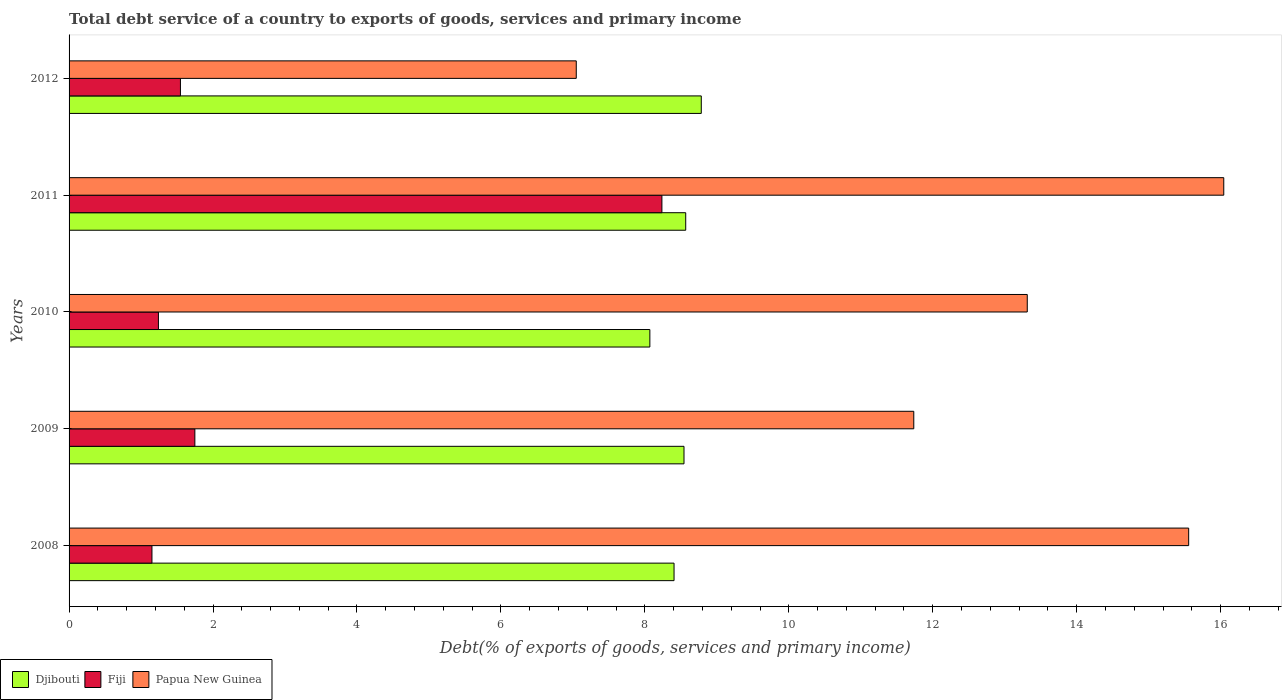How many different coloured bars are there?
Ensure brevity in your answer.  3. How many groups of bars are there?
Provide a short and direct response. 5. Are the number of bars per tick equal to the number of legend labels?
Offer a very short reply. Yes. What is the label of the 3rd group of bars from the top?
Ensure brevity in your answer.  2010. What is the total debt service in Papua New Guinea in 2010?
Your answer should be compact. 13.31. Across all years, what is the maximum total debt service in Papua New Guinea?
Keep it short and to the point. 16.04. Across all years, what is the minimum total debt service in Papua New Guinea?
Your answer should be very brief. 7.05. In which year was the total debt service in Fiji minimum?
Ensure brevity in your answer.  2008. What is the total total debt service in Fiji in the graph?
Provide a short and direct response. 13.93. What is the difference between the total debt service in Fiji in 2008 and that in 2011?
Your answer should be very brief. -7.09. What is the difference between the total debt service in Djibouti in 2009 and the total debt service in Fiji in 2008?
Your response must be concise. 7.39. What is the average total debt service in Djibouti per year?
Your answer should be compact. 8.47. In the year 2009, what is the difference between the total debt service in Fiji and total debt service in Papua New Guinea?
Offer a very short reply. -9.99. What is the ratio of the total debt service in Djibouti in 2010 to that in 2012?
Your response must be concise. 0.92. What is the difference between the highest and the second highest total debt service in Fiji?
Provide a succinct answer. 6.49. What is the difference between the highest and the lowest total debt service in Fiji?
Keep it short and to the point. 7.09. What does the 2nd bar from the top in 2010 represents?
Your response must be concise. Fiji. What does the 3rd bar from the bottom in 2012 represents?
Make the answer very short. Papua New Guinea. Is it the case that in every year, the sum of the total debt service in Papua New Guinea and total debt service in Fiji is greater than the total debt service in Djibouti?
Keep it short and to the point. No. Does the graph contain any zero values?
Ensure brevity in your answer.  No. Does the graph contain grids?
Offer a very short reply. No. Where does the legend appear in the graph?
Provide a short and direct response. Bottom left. How many legend labels are there?
Offer a terse response. 3. What is the title of the graph?
Offer a terse response. Total debt service of a country to exports of goods, services and primary income. What is the label or title of the X-axis?
Your answer should be compact. Debt(% of exports of goods, services and primary income). What is the label or title of the Y-axis?
Your answer should be compact. Years. What is the Debt(% of exports of goods, services and primary income) of Djibouti in 2008?
Provide a succinct answer. 8.41. What is the Debt(% of exports of goods, services and primary income) in Fiji in 2008?
Your answer should be very brief. 1.15. What is the Debt(% of exports of goods, services and primary income) of Papua New Guinea in 2008?
Offer a very short reply. 15.56. What is the Debt(% of exports of goods, services and primary income) of Djibouti in 2009?
Your answer should be compact. 8.54. What is the Debt(% of exports of goods, services and primary income) of Fiji in 2009?
Offer a terse response. 1.75. What is the Debt(% of exports of goods, services and primary income) of Papua New Guinea in 2009?
Your response must be concise. 11.74. What is the Debt(% of exports of goods, services and primary income) of Djibouti in 2010?
Make the answer very short. 8.07. What is the Debt(% of exports of goods, services and primary income) in Fiji in 2010?
Your answer should be compact. 1.24. What is the Debt(% of exports of goods, services and primary income) in Papua New Guinea in 2010?
Ensure brevity in your answer.  13.31. What is the Debt(% of exports of goods, services and primary income) in Djibouti in 2011?
Your response must be concise. 8.57. What is the Debt(% of exports of goods, services and primary income) in Fiji in 2011?
Give a very brief answer. 8.24. What is the Debt(% of exports of goods, services and primary income) in Papua New Guinea in 2011?
Give a very brief answer. 16.04. What is the Debt(% of exports of goods, services and primary income) in Djibouti in 2012?
Keep it short and to the point. 8.78. What is the Debt(% of exports of goods, services and primary income) in Fiji in 2012?
Provide a succinct answer. 1.55. What is the Debt(% of exports of goods, services and primary income) of Papua New Guinea in 2012?
Provide a succinct answer. 7.05. Across all years, what is the maximum Debt(% of exports of goods, services and primary income) of Djibouti?
Ensure brevity in your answer.  8.78. Across all years, what is the maximum Debt(% of exports of goods, services and primary income) of Fiji?
Make the answer very short. 8.24. Across all years, what is the maximum Debt(% of exports of goods, services and primary income) of Papua New Guinea?
Give a very brief answer. 16.04. Across all years, what is the minimum Debt(% of exports of goods, services and primary income) of Djibouti?
Offer a terse response. 8.07. Across all years, what is the minimum Debt(% of exports of goods, services and primary income) of Fiji?
Offer a terse response. 1.15. Across all years, what is the minimum Debt(% of exports of goods, services and primary income) of Papua New Guinea?
Offer a terse response. 7.05. What is the total Debt(% of exports of goods, services and primary income) of Djibouti in the graph?
Provide a succinct answer. 42.37. What is the total Debt(% of exports of goods, services and primary income) of Fiji in the graph?
Provide a short and direct response. 13.93. What is the total Debt(% of exports of goods, services and primary income) in Papua New Guinea in the graph?
Keep it short and to the point. 63.7. What is the difference between the Debt(% of exports of goods, services and primary income) of Djibouti in 2008 and that in 2009?
Your answer should be very brief. -0.14. What is the difference between the Debt(% of exports of goods, services and primary income) in Fiji in 2008 and that in 2009?
Provide a succinct answer. -0.6. What is the difference between the Debt(% of exports of goods, services and primary income) of Papua New Guinea in 2008 and that in 2009?
Your answer should be very brief. 3.82. What is the difference between the Debt(% of exports of goods, services and primary income) in Djibouti in 2008 and that in 2010?
Your response must be concise. 0.34. What is the difference between the Debt(% of exports of goods, services and primary income) of Fiji in 2008 and that in 2010?
Make the answer very short. -0.09. What is the difference between the Debt(% of exports of goods, services and primary income) in Papua New Guinea in 2008 and that in 2010?
Offer a very short reply. 2.24. What is the difference between the Debt(% of exports of goods, services and primary income) of Djibouti in 2008 and that in 2011?
Give a very brief answer. -0.16. What is the difference between the Debt(% of exports of goods, services and primary income) in Fiji in 2008 and that in 2011?
Provide a short and direct response. -7.09. What is the difference between the Debt(% of exports of goods, services and primary income) of Papua New Guinea in 2008 and that in 2011?
Make the answer very short. -0.49. What is the difference between the Debt(% of exports of goods, services and primary income) of Djibouti in 2008 and that in 2012?
Make the answer very short. -0.38. What is the difference between the Debt(% of exports of goods, services and primary income) of Fiji in 2008 and that in 2012?
Give a very brief answer. -0.4. What is the difference between the Debt(% of exports of goods, services and primary income) in Papua New Guinea in 2008 and that in 2012?
Ensure brevity in your answer.  8.51. What is the difference between the Debt(% of exports of goods, services and primary income) in Djibouti in 2009 and that in 2010?
Give a very brief answer. 0.47. What is the difference between the Debt(% of exports of goods, services and primary income) in Fiji in 2009 and that in 2010?
Ensure brevity in your answer.  0.51. What is the difference between the Debt(% of exports of goods, services and primary income) in Papua New Guinea in 2009 and that in 2010?
Your answer should be compact. -1.58. What is the difference between the Debt(% of exports of goods, services and primary income) of Djibouti in 2009 and that in 2011?
Offer a very short reply. -0.02. What is the difference between the Debt(% of exports of goods, services and primary income) of Fiji in 2009 and that in 2011?
Give a very brief answer. -6.49. What is the difference between the Debt(% of exports of goods, services and primary income) of Papua New Guinea in 2009 and that in 2011?
Give a very brief answer. -4.31. What is the difference between the Debt(% of exports of goods, services and primary income) of Djibouti in 2009 and that in 2012?
Offer a very short reply. -0.24. What is the difference between the Debt(% of exports of goods, services and primary income) of Fiji in 2009 and that in 2012?
Your answer should be compact. 0.2. What is the difference between the Debt(% of exports of goods, services and primary income) in Papua New Guinea in 2009 and that in 2012?
Give a very brief answer. 4.69. What is the difference between the Debt(% of exports of goods, services and primary income) of Djibouti in 2010 and that in 2011?
Your response must be concise. -0.5. What is the difference between the Debt(% of exports of goods, services and primary income) of Fiji in 2010 and that in 2011?
Offer a terse response. -7. What is the difference between the Debt(% of exports of goods, services and primary income) in Papua New Guinea in 2010 and that in 2011?
Provide a succinct answer. -2.73. What is the difference between the Debt(% of exports of goods, services and primary income) in Djibouti in 2010 and that in 2012?
Provide a short and direct response. -0.71. What is the difference between the Debt(% of exports of goods, services and primary income) in Fiji in 2010 and that in 2012?
Ensure brevity in your answer.  -0.31. What is the difference between the Debt(% of exports of goods, services and primary income) in Papua New Guinea in 2010 and that in 2012?
Provide a short and direct response. 6.27. What is the difference between the Debt(% of exports of goods, services and primary income) in Djibouti in 2011 and that in 2012?
Offer a very short reply. -0.22. What is the difference between the Debt(% of exports of goods, services and primary income) of Fiji in 2011 and that in 2012?
Provide a succinct answer. 6.69. What is the difference between the Debt(% of exports of goods, services and primary income) of Papua New Guinea in 2011 and that in 2012?
Your response must be concise. 9. What is the difference between the Debt(% of exports of goods, services and primary income) in Djibouti in 2008 and the Debt(% of exports of goods, services and primary income) in Fiji in 2009?
Your answer should be very brief. 6.66. What is the difference between the Debt(% of exports of goods, services and primary income) in Djibouti in 2008 and the Debt(% of exports of goods, services and primary income) in Papua New Guinea in 2009?
Your answer should be compact. -3.33. What is the difference between the Debt(% of exports of goods, services and primary income) in Fiji in 2008 and the Debt(% of exports of goods, services and primary income) in Papua New Guinea in 2009?
Give a very brief answer. -10.59. What is the difference between the Debt(% of exports of goods, services and primary income) of Djibouti in 2008 and the Debt(% of exports of goods, services and primary income) of Fiji in 2010?
Your answer should be very brief. 7.16. What is the difference between the Debt(% of exports of goods, services and primary income) of Djibouti in 2008 and the Debt(% of exports of goods, services and primary income) of Papua New Guinea in 2010?
Your response must be concise. -4.91. What is the difference between the Debt(% of exports of goods, services and primary income) in Fiji in 2008 and the Debt(% of exports of goods, services and primary income) in Papua New Guinea in 2010?
Your answer should be very brief. -12.16. What is the difference between the Debt(% of exports of goods, services and primary income) in Djibouti in 2008 and the Debt(% of exports of goods, services and primary income) in Fiji in 2011?
Your response must be concise. 0.17. What is the difference between the Debt(% of exports of goods, services and primary income) of Djibouti in 2008 and the Debt(% of exports of goods, services and primary income) of Papua New Guinea in 2011?
Your response must be concise. -7.64. What is the difference between the Debt(% of exports of goods, services and primary income) in Fiji in 2008 and the Debt(% of exports of goods, services and primary income) in Papua New Guinea in 2011?
Provide a succinct answer. -14.89. What is the difference between the Debt(% of exports of goods, services and primary income) in Djibouti in 2008 and the Debt(% of exports of goods, services and primary income) in Fiji in 2012?
Provide a short and direct response. 6.86. What is the difference between the Debt(% of exports of goods, services and primary income) in Djibouti in 2008 and the Debt(% of exports of goods, services and primary income) in Papua New Guinea in 2012?
Your response must be concise. 1.36. What is the difference between the Debt(% of exports of goods, services and primary income) of Fiji in 2008 and the Debt(% of exports of goods, services and primary income) of Papua New Guinea in 2012?
Make the answer very short. -5.9. What is the difference between the Debt(% of exports of goods, services and primary income) of Djibouti in 2009 and the Debt(% of exports of goods, services and primary income) of Fiji in 2010?
Your response must be concise. 7.3. What is the difference between the Debt(% of exports of goods, services and primary income) in Djibouti in 2009 and the Debt(% of exports of goods, services and primary income) in Papua New Guinea in 2010?
Keep it short and to the point. -4.77. What is the difference between the Debt(% of exports of goods, services and primary income) of Fiji in 2009 and the Debt(% of exports of goods, services and primary income) of Papua New Guinea in 2010?
Your response must be concise. -11.57. What is the difference between the Debt(% of exports of goods, services and primary income) in Djibouti in 2009 and the Debt(% of exports of goods, services and primary income) in Fiji in 2011?
Make the answer very short. 0.31. What is the difference between the Debt(% of exports of goods, services and primary income) of Djibouti in 2009 and the Debt(% of exports of goods, services and primary income) of Papua New Guinea in 2011?
Your response must be concise. -7.5. What is the difference between the Debt(% of exports of goods, services and primary income) of Fiji in 2009 and the Debt(% of exports of goods, services and primary income) of Papua New Guinea in 2011?
Your answer should be very brief. -14.3. What is the difference between the Debt(% of exports of goods, services and primary income) in Djibouti in 2009 and the Debt(% of exports of goods, services and primary income) in Fiji in 2012?
Give a very brief answer. 7. What is the difference between the Debt(% of exports of goods, services and primary income) in Djibouti in 2009 and the Debt(% of exports of goods, services and primary income) in Papua New Guinea in 2012?
Provide a succinct answer. 1.5. What is the difference between the Debt(% of exports of goods, services and primary income) in Fiji in 2009 and the Debt(% of exports of goods, services and primary income) in Papua New Guinea in 2012?
Provide a succinct answer. -5.3. What is the difference between the Debt(% of exports of goods, services and primary income) in Djibouti in 2010 and the Debt(% of exports of goods, services and primary income) in Fiji in 2011?
Provide a succinct answer. -0.17. What is the difference between the Debt(% of exports of goods, services and primary income) of Djibouti in 2010 and the Debt(% of exports of goods, services and primary income) of Papua New Guinea in 2011?
Give a very brief answer. -7.97. What is the difference between the Debt(% of exports of goods, services and primary income) in Fiji in 2010 and the Debt(% of exports of goods, services and primary income) in Papua New Guinea in 2011?
Keep it short and to the point. -14.8. What is the difference between the Debt(% of exports of goods, services and primary income) of Djibouti in 2010 and the Debt(% of exports of goods, services and primary income) of Fiji in 2012?
Offer a very short reply. 6.52. What is the difference between the Debt(% of exports of goods, services and primary income) of Djibouti in 2010 and the Debt(% of exports of goods, services and primary income) of Papua New Guinea in 2012?
Offer a terse response. 1.02. What is the difference between the Debt(% of exports of goods, services and primary income) of Fiji in 2010 and the Debt(% of exports of goods, services and primary income) of Papua New Guinea in 2012?
Keep it short and to the point. -5.81. What is the difference between the Debt(% of exports of goods, services and primary income) of Djibouti in 2011 and the Debt(% of exports of goods, services and primary income) of Fiji in 2012?
Your answer should be compact. 7.02. What is the difference between the Debt(% of exports of goods, services and primary income) in Djibouti in 2011 and the Debt(% of exports of goods, services and primary income) in Papua New Guinea in 2012?
Make the answer very short. 1.52. What is the difference between the Debt(% of exports of goods, services and primary income) in Fiji in 2011 and the Debt(% of exports of goods, services and primary income) in Papua New Guinea in 2012?
Offer a terse response. 1.19. What is the average Debt(% of exports of goods, services and primary income) in Djibouti per year?
Ensure brevity in your answer.  8.47. What is the average Debt(% of exports of goods, services and primary income) of Fiji per year?
Your answer should be compact. 2.79. What is the average Debt(% of exports of goods, services and primary income) of Papua New Guinea per year?
Provide a succinct answer. 12.74. In the year 2008, what is the difference between the Debt(% of exports of goods, services and primary income) in Djibouti and Debt(% of exports of goods, services and primary income) in Fiji?
Give a very brief answer. 7.25. In the year 2008, what is the difference between the Debt(% of exports of goods, services and primary income) of Djibouti and Debt(% of exports of goods, services and primary income) of Papua New Guinea?
Your response must be concise. -7.15. In the year 2008, what is the difference between the Debt(% of exports of goods, services and primary income) in Fiji and Debt(% of exports of goods, services and primary income) in Papua New Guinea?
Offer a very short reply. -14.4. In the year 2009, what is the difference between the Debt(% of exports of goods, services and primary income) of Djibouti and Debt(% of exports of goods, services and primary income) of Fiji?
Offer a very short reply. 6.8. In the year 2009, what is the difference between the Debt(% of exports of goods, services and primary income) in Djibouti and Debt(% of exports of goods, services and primary income) in Papua New Guinea?
Keep it short and to the point. -3.19. In the year 2009, what is the difference between the Debt(% of exports of goods, services and primary income) of Fiji and Debt(% of exports of goods, services and primary income) of Papua New Guinea?
Keep it short and to the point. -9.99. In the year 2010, what is the difference between the Debt(% of exports of goods, services and primary income) of Djibouti and Debt(% of exports of goods, services and primary income) of Fiji?
Give a very brief answer. 6.83. In the year 2010, what is the difference between the Debt(% of exports of goods, services and primary income) of Djibouti and Debt(% of exports of goods, services and primary income) of Papua New Guinea?
Your answer should be compact. -5.24. In the year 2010, what is the difference between the Debt(% of exports of goods, services and primary income) in Fiji and Debt(% of exports of goods, services and primary income) in Papua New Guinea?
Provide a succinct answer. -12.07. In the year 2011, what is the difference between the Debt(% of exports of goods, services and primary income) of Djibouti and Debt(% of exports of goods, services and primary income) of Fiji?
Make the answer very short. 0.33. In the year 2011, what is the difference between the Debt(% of exports of goods, services and primary income) in Djibouti and Debt(% of exports of goods, services and primary income) in Papua New Guinea?
Make the answer very short. -7.48. In the year 2011, what is the difference between the Debt(% of exports of goods, services and primary income) in Fiji and Debt(% of exports of goods, services and primary income) in Papua New Guinea?
Keep it short and to the point. -7.81. In the year 2012, what is the difference between the Debt(% of exports of goods, services and primary income) in Djibouti and Debt(% of exports of goods, services and primary income) in Fiji?
Your answer should be very brief. 7.24. In the year 2012, what is the difference between the Debt(% of exports of goods, services and primary income) of Djibouti and Debt(% of exports of goods, services and primary income) of Papua New Guinea?
Make the answer very short. 1.74. In the year 2012, what is the difference between the Debt(% of exports of goods, services and primary income) in Fiji and Debt(% of exports of goods, services and primary income) in Papua New Guinea?
Keep it short and to the point. -5.5. What is the ratio of the Debt(% of exports of goods, services and primary income) in Djibouti in 2008 to that in 2009?
Offer a terse response. 0.98. What is the ratio of the Debt(% of exports of goods, services and primary income) of Fiji in 2008 to that in 2009?
Your answer should be compact. 0.66. What is the ratio of the Debt(% of exports of goods, services and primary income) of Papua New Guinea in 2008 to that in 2009?
Keep it short and to the point. 1.33. What is the ratio of the Debt(% of exports of goods, services and primary income) of Djibouti in 2008 to that in 2010?
Keep it short and to the point. 1.04. What is the ratio of the Debt(% of exports of goods, services and primary income) in Fiji in 2008 to that in 2010?
Offer a very short reply. 0.93. What is the ratio of the Debt(% of exports of goods, services and primary income) of Papua New Guinea in 2008 to that in 2010?
Your answer should be very brief. 1.17. What is the ratio of the Debt(% of exports of goods, services and primary income) in Djibouti in 2008 to that in 2011?
Your answer should be compact. 0.98. What is the ratio of the Debt(% of exports of goods, services and primary income) in Fiji in 2008 to that in 2011?
Ensure brevity in your answer.  0.14. What is the ratio of the Debt(% of exports of goods, services and primary income) in Papua New Guinea in 2008 to that in 2011?
Keep it short and to the point. 0.97. What is the ratio of the Debt(% of exports of goods, services and primary income) in Djibouti in 2008 to that in 2012?
Your response must be concise. 0.96. What is the ratio of the Debt(% of exports of goods, services and primary income) of Fiji in 2008 to that in 2012?
Your response must be concise. 0.74. What is the ratio of the Debt(% of exports of goods, services and primary income) in Papua New Guinea in 2008 to that in 2012?
Provide a short and direct response. 2.21. What is the ratio of the Debt(% of exports of goods, services and primary income) in Djibouti in 2009 to that in 2010?
Ensure brevity in your answer.  1.06. What is the ratio of the Debt(% of exports of goods, services and primary income) in Fiji in 2009 to that in 2010?
Keep it short and to the point. 1.41. What is the ratio of the Debt(% of exports of goods, services and primary income) in Papua New Guinea in 2009 to that in 2010?
Your answer should be very brief. 0.88. What is the ratio of the Debt(% of exports of goods, services and primary income) in Djibouti in 2009 to that in 2011?
Your response must be concise. 1. What is the ratio of the Debt(% of exports of goods, services and primary income) of Fiji in 2009 to that in 2011?
Provide a succinct answer. 0.21. What is the ratio of the Debt(% of exports of goods, services and primary income) of Papua New Guinea in 2009 to that in 2011?
Keep it short and to the point. 0.73. What is the ratio of the Debt(% of exports of goods, services and primary income) of Djibouti in 2009 to that in 2012?
Provide a succinct answer. 0.97. What is the ratio of the Debt(% of exports of goods, services and primary income) in Fiji in 2009 to that in 2012?
Offer a terse response. 1.13. What is the ratio of the Debt(% of exports of goods, services and primary income) in Papua New Guinea in 2009 to that in 2012?
Offer a terse response. 1.67. What is the ratio of the Debt(% of exports of goods, services and primary income) of Djibouti in 2010 to that in 2011?
Provide a succinct answer. 0.94. What is the ratio of the Debt(% of exports of goods, services and primary income) of Fiji in 2010 to that in 2011?
Ensure brevity in your answer.  0.15. What is the ratio of the Debt(% of exports of goods, services and primary income) of Papua New Guinea in 2010 to that in 2011?
Offer a terse response. 0.83. What is the ratio of the Debt(% of exports of goods, services and primary income) of Djibouti in 2010 to that in 2012?
Ensure brevity in your answer.  0.92. What is the ratio of the Debt(% of exports of goods, services and primary income) in Fiji in 2010 to that in 2012?
Your answer should be very brief. 0.8. What is the ratio of the Debt(% of exports of goods, services and primary income) of Papua New Guinea in 2010 to that in 2012?
Provide a succinct answer. 1.89. What is the ratio of the Debt(% of exports of goods, services and primary income) in Djibouti in 2011 to that in 2012?
Make the answer very short. 0.98. What is the ratio of the Debt(% of exports of goods, services and primary income) of Fiji in 2011 to that in 2012?
Give a very brief answer. 5.32. What is the ratio of the Debt(% of exports of goods, services and primary income) in Papua New Guinea in 2011 to that in 2012?
Ensure brevity in your answer.  2.28. What is the difference between the highest and the second highest Debt(% of exports of goods, services and primary income) in Djibouti?
Your response must be concise. 0.22. What is the difference between the highest and the second highest Debt(% of exports of goods, services and primary income) of Fiji?
Offer a very short reply. 6.49. What is the difference between the highest and the second highest Debt(% of exports of goods, services and primary income) in Papua New Guinea?
Provide a short and direct response. 0.49. What is the difference between the highest and the lowest Debt(% of exports of goods, services and primary income) of Djibouti?
Your response must be concise. 0.71. What is the difference between the highest and the lowest Debt(% of exports of goods, services and primary income) of Fiji?
Your response must be concise. 7.09. What is the difference between the highest and the lowest Debt(% of exports of goods, services and primary income) of Papua New Guinea?
Your answer should be very brief. 9. 